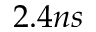Convert formula to latex. <formula><loc_0><loc_0><loc_500><loc_500>2 . 4 n s</formula> 